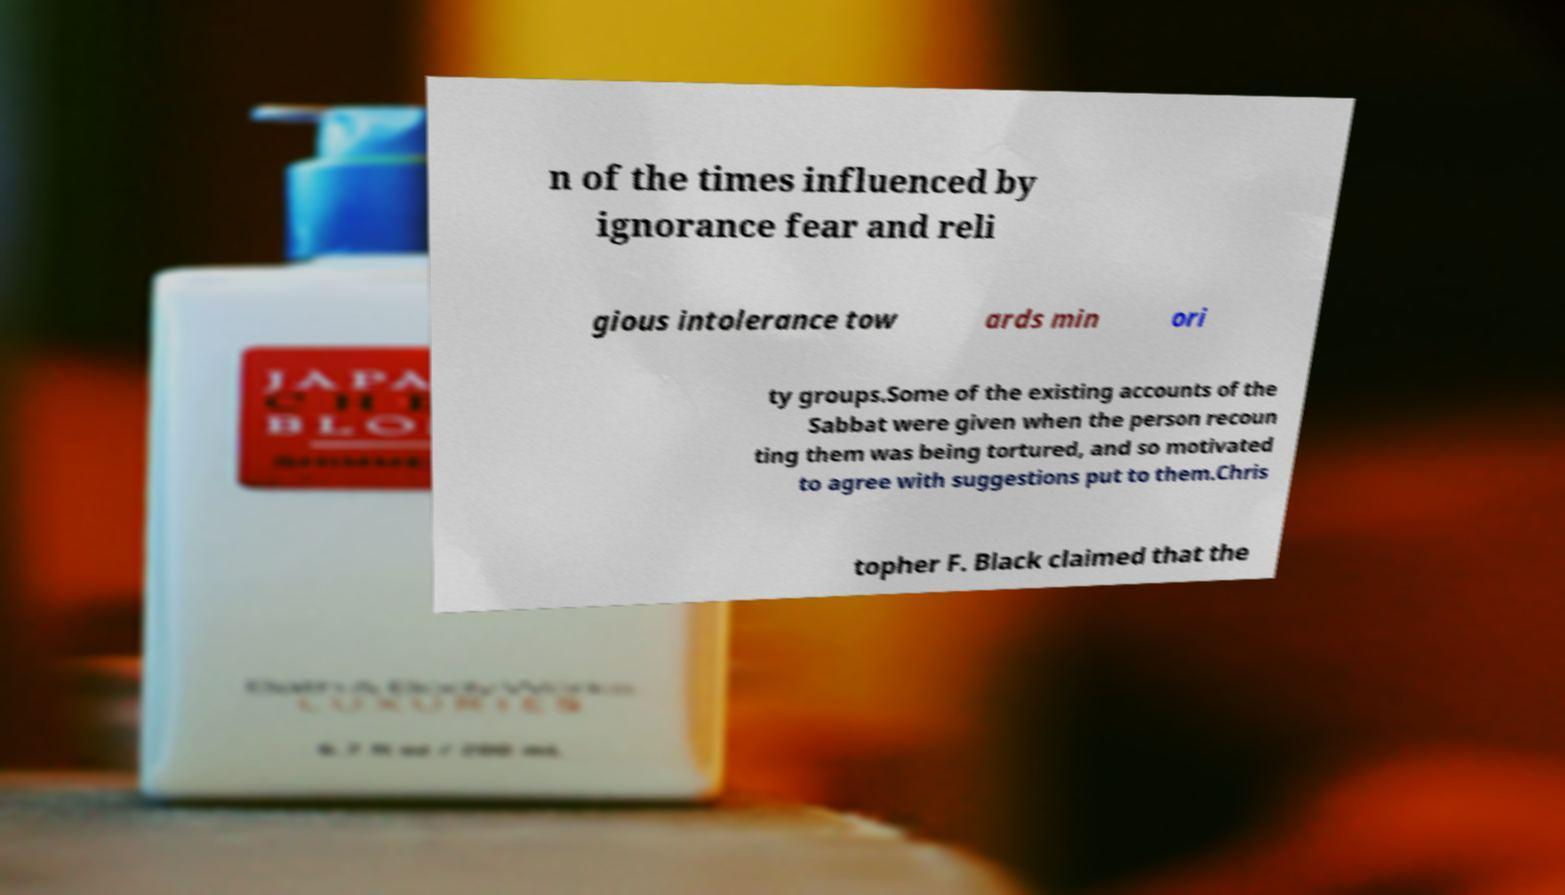For documentation purposes, I need the text within this image transcribed. Could you provide that? n of the times influenced by ignorance fear and reli gious intolerance tow ards min ori ty groups.Some of the existing accounts of the Sabbat were given when the person recoun ting them was being tortured, and so motivated to agree with suggestions put to them.Chris topher F. Black claimed that the 